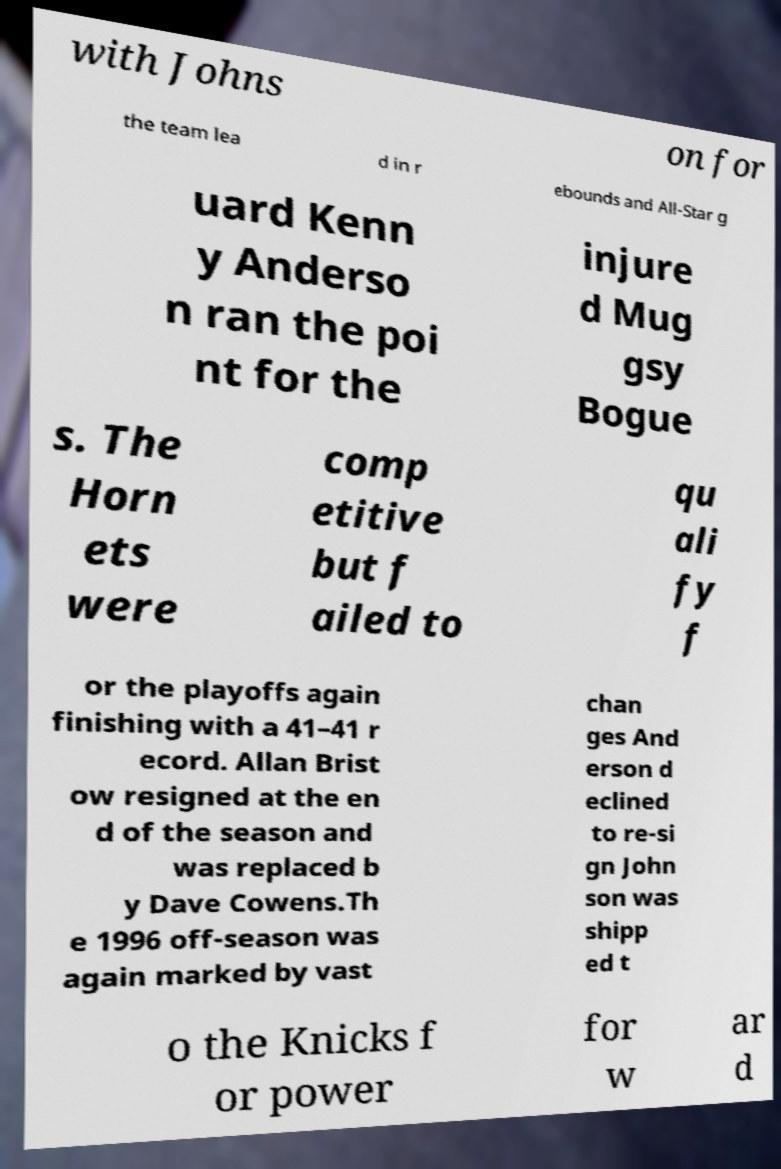Could you assist in decoding the text presented in this image and type it out clearly? with Johns on for the team lea d in r ebounds and All-Star g uard Kenn y Anderso n ran the poi nt for the injure d Mug gsy Bogue s. The Horn ets were comp etitive but f ailed to qu ali fy f or the playoffs again finishing with a 41–41 r ecord. Allan Brist ow resigned at the en d of the season and was replaced b y Dave Cowens.Th e 1996 off-season was again marked by vast chan ges And erson d eclined to re-si gn John son was shipp ed t o the Knicks f or power for w ar d 